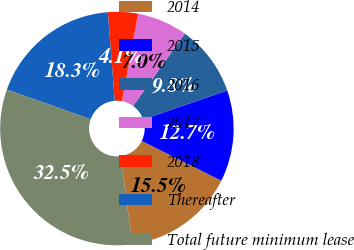<chart> <loc_0><loc_0><loc_500><loc_500><pie_chart><fcel>2014<fcel>2015<fcel>2016<fcel>2017<fcel>2018<fcel>Thereafter<fcel>Total future minimum lease<nl><fcel>15.5%<fcel>12.66%<fcel>9.82%<fcel>6.98%<fcel>4.14%<fcel>18.34%<fcel>32.54%<nl></chart> 